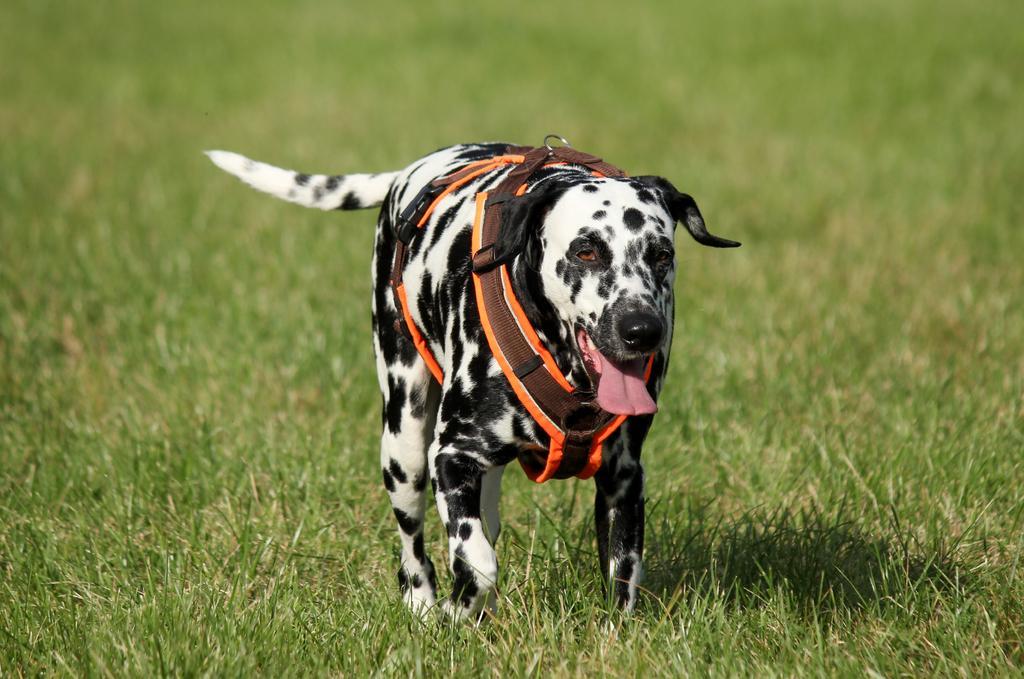In one or two sentences, can you explain what this image depicts? In the center of the image we can see a dog. At the bottom there is grass. 